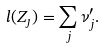Convert formula to latex. <formula><loc_0><loc_0><loc_500><loc_500>l ( Z _ { \jmath } ) = \sum _ { j } \nu _ { j } ^ { \prime } .</formula> 